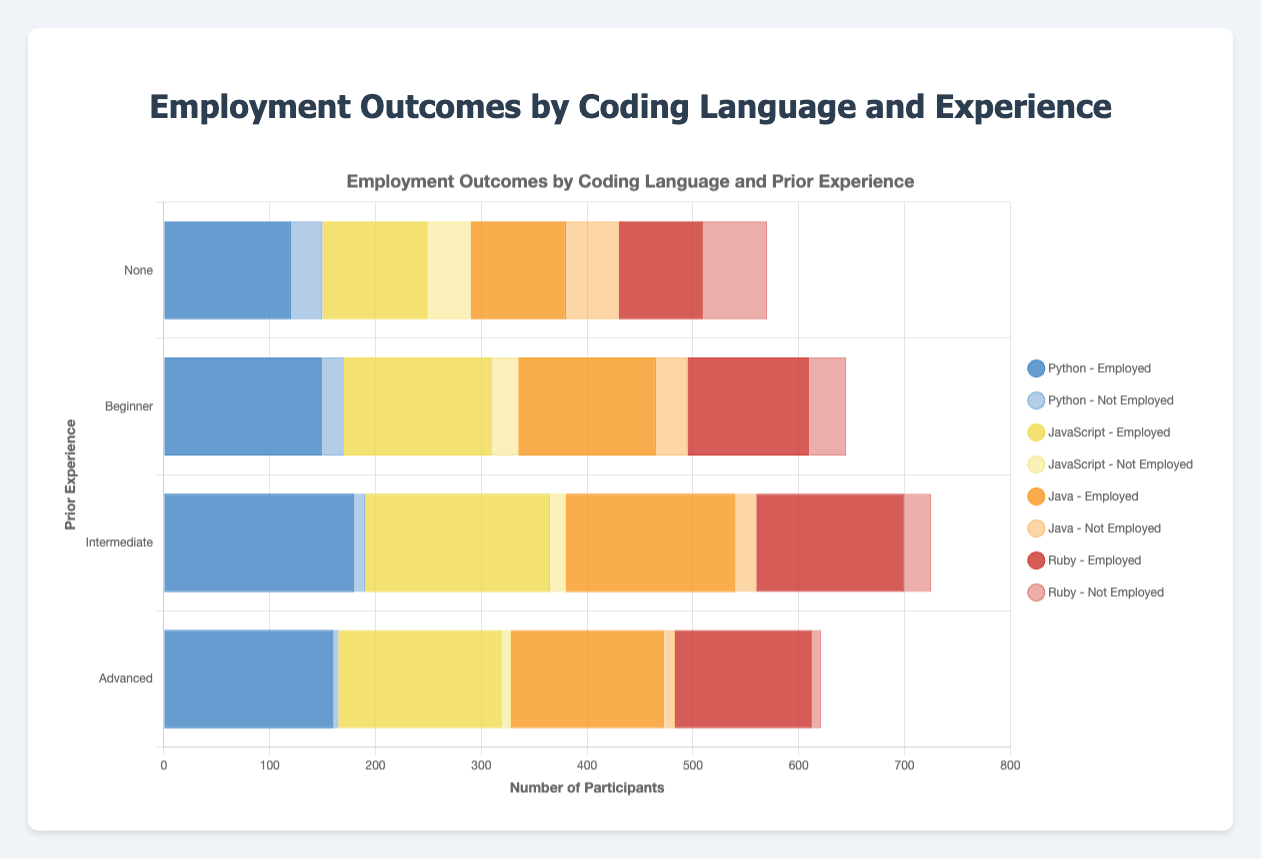Which coding language had the highest employment outcome for participants with no prior experience? For "no" prior experience, compare the employment counts: Python (120), JavaScript (100), Java (90), Ruby (80). Python has the highest count.
Answer: Python What is the total number of employed participants who learned JavaScript and had intermediate prior experience? JavaScript+Intermediate: 175 employed participants
Answer: 175 Which coding language shows the biggest difference in employment outcomes between those with beginner and advanced experience levels? Calculate the differences: Python (10), JavaScript (15), Java (15), Ruby (15). All show the same largest difference.
Answer: Python, JavaScript, Java, Ruby How many participants with intermediate prior experience were not employed after learning any coding language? Sum not employed counts for intermediate experience: Python (10) + JavaScript (15) + Java (20) + Ruby (25)= 70.
Answer: 70 Which group of participants (by coding language and experience) had the highest number of not employed individuals? Compare the not employed counts across all groups. Ruby with no prior experience has the highest (60).
Answer: Ruby with no prior experience What is the average number of employed participants who had advanced experience regardless of the coding language? For advanced experience: Python (160) + JavaScript (155) + Java (145) + Ruby (130) = 590. Average is 590/4 = 147.5.
Answer: 147.5 Which coding language had the most consistent (least variation) employment outcomes across all experience levels? Python: employed (120, 150, 180, 160) = range 60. JavaScript: (100, 140, 175, 155) = range 75. Java: (90, 130, 160, 145) = range 70. Ruby: (80, 115, 140, 130) = range 60. Therefore, Python and Ruby have the least variation.
Answer: Python, Ruby Which experience level had the highest overall number of employed participants regardless of coding language? Sum employed counts by experience level: None (120+100+90+80=390), Beginner (150+140+130+115=535), Intermediate (180+175+160+140=655), Advanced (160+155+145+130=590). Intermediate has the highest.
Answer: Intermediate What is the difference between the total number of employed and not employed participants for Python? Python: employed total (120+150+180+160=610), not employed total (30+20+10+5=65). Difference = 610 - 65 = 545.
Answer: 545 Comparing Java and Ruby, which has a higher employment outcome for those with beginner experience levels? Java Beginner (130 employed) vs. Ruby Beginner (115 employed). Java has higher employment outcome.
Answer: Java 